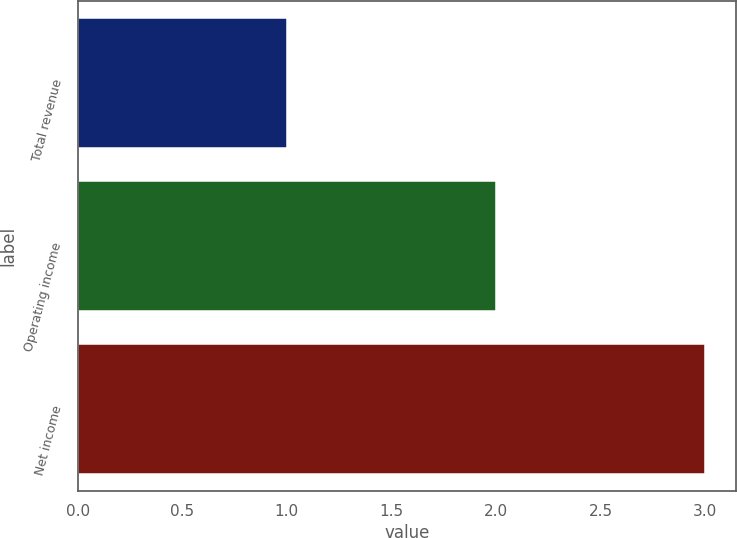<chart> <loc_0><loc_0><loc_500><loc_500><bar_chart><fcel>Total revenue<fcel>Operating income<fcel>Net income<nl><fcel>1<fcel>2<fcel>3<nl></chart> 